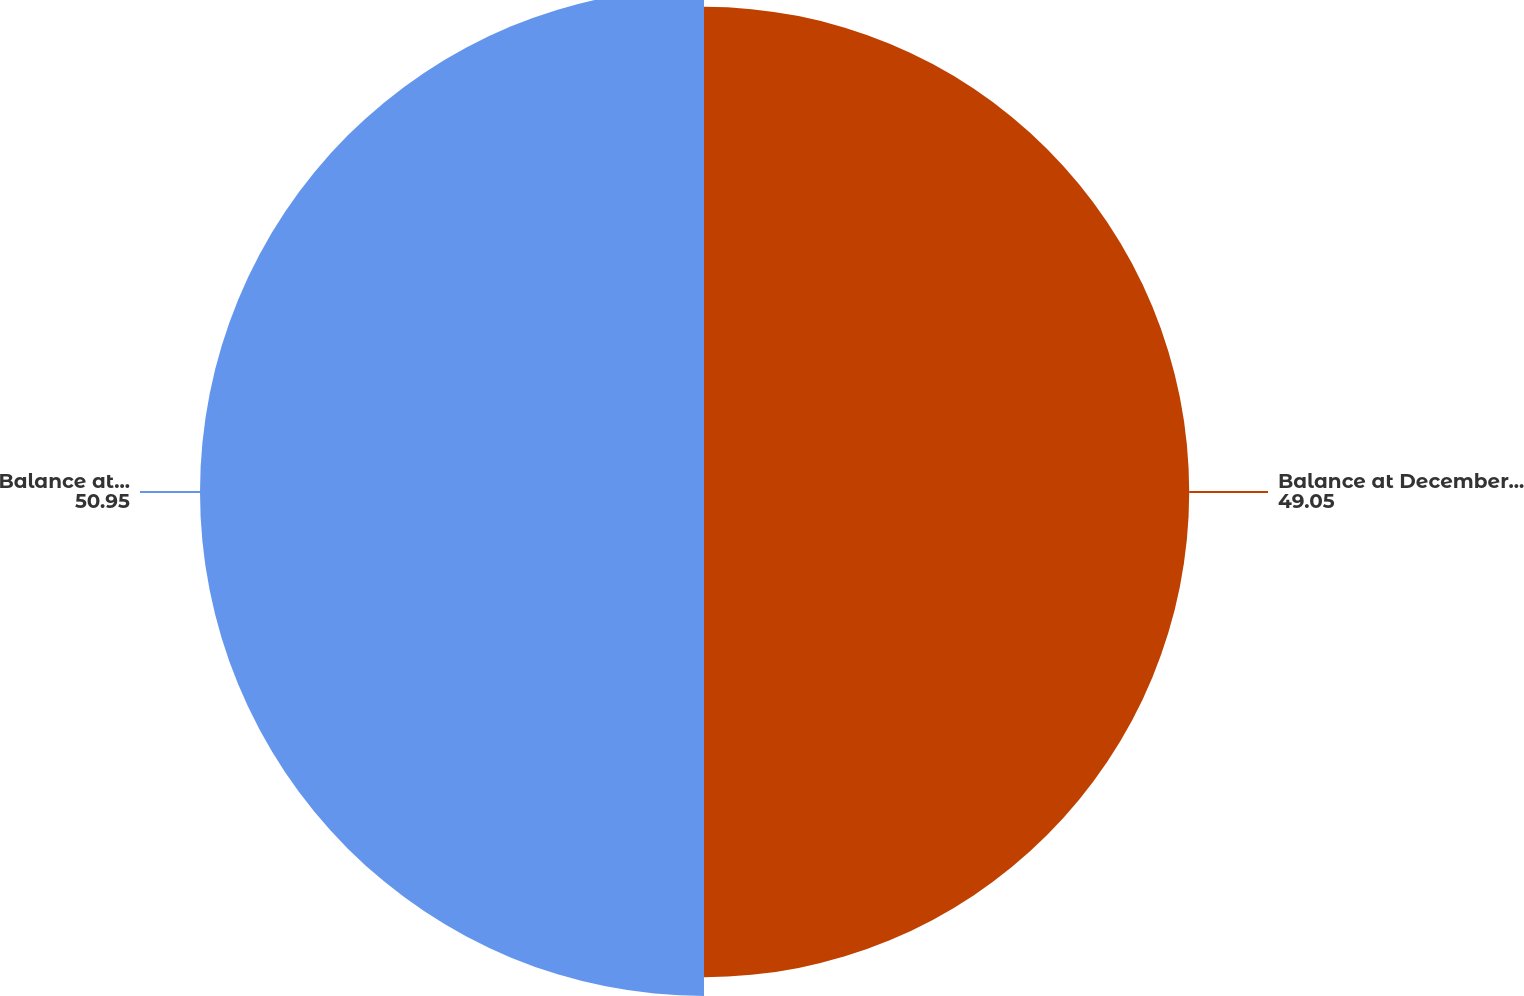<chart> <loc_0><loc_0><loc_500><loc_500><pie_chart><fcel>Balance at December 31 2013<fcel>Balance at December 31 2014<nl><fcel>49.05%<fcel>50.95%<nl></chart> 